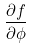<formula> <loc_0><loc_0><loc_500><loc_500>\frac { \partial f } { \partial \phi }</formula> 